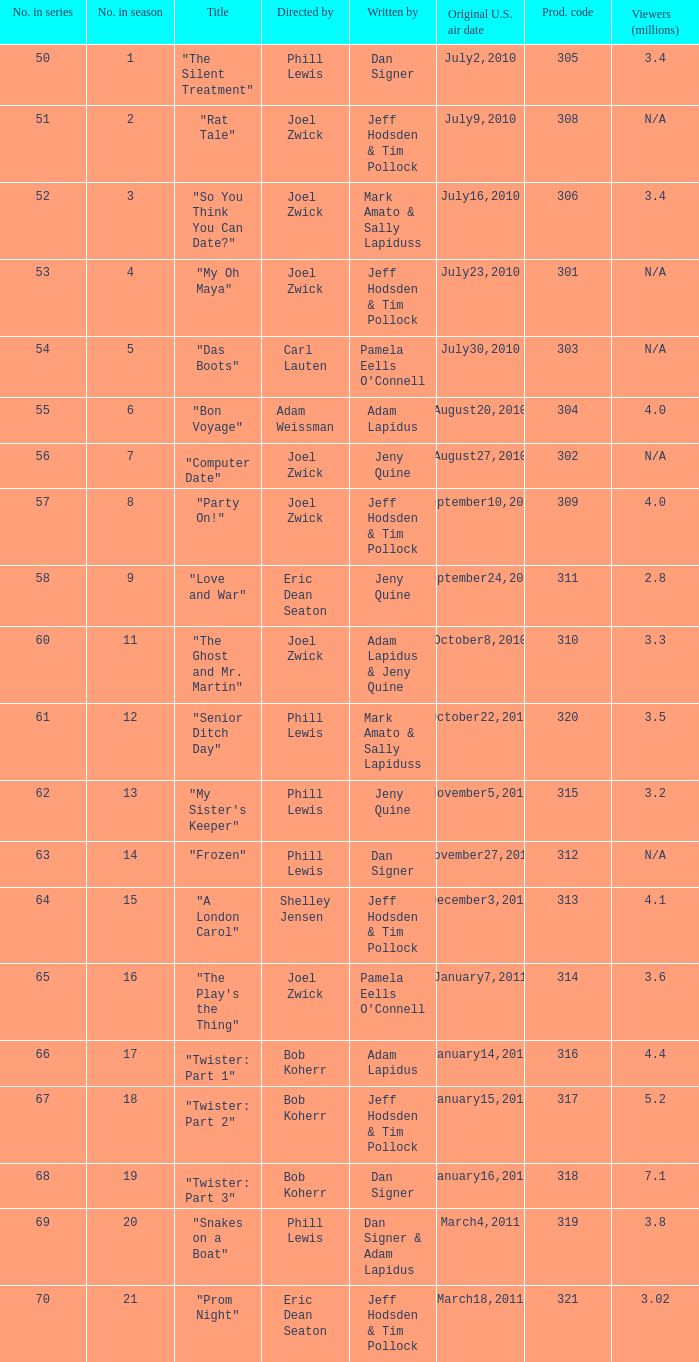Who was the directed for the episode titled "twister: part 1"? Bob Koherr. Would you be able to parse every entry in this table? {'header': ['No. in series', 'No. in season', 'Title', 'Directed by', 'Written by', 'Original U.S. air date', 'Prod. code', 'Viewers (millions)'], 'rows': [['50', '1', '"The Silent Treatment"', 'Phill Lewis', 'Dan Signer', 'July2,2010', '305', '3.4'], ['51', '2', '"Rat Tale"', 'Joel Zwick', 'Jeff Hodsden & Tim Pollock', 'July9,2010', '308', 'N/A'], ['52', '3', '"So You Think You Can Date?"', 'Joel Zwick', 'Mark Amato & Sally Lapiduss', 'July16,2010', '306', '3.4'], ['53', '4', '"My Oh Maya"', 'Joel Zwick', 'Jeff Hodsden & Tim Pollock', 'July23,2010', '301', 'N/A'], ['54', '5', '"Das Boots"', 'Carl Lauten', "Pamela Eells O'Connell", 'July30,2010', '303', 'N/A'], ['55', '6', '"Bon Voyage"', 'Adam Weissman', 'Adam Lapidus', 'August20,2010', '304', '4.0'], ['56', '7', '"Computer Date"', 'Joel Zwick', 'Jeny Quine', 'August27,2010', '302', 'N/A'], ['57', '8', '"Party On!"', 'Joel Zwick', 'Jeff Hodsden & Tim Pollock', 'September10,2010', '309', '4.0'], ['58', '9', '"Love and War"', 'Eric Dean Seaton', 'Jeny Quine', 'September24,2010', '311', '2.8'], ['60', '11', '"The Ghost and Mr. Martin"', 'Joel Zwick', 'Adam Lapidus & Jeny Quine', 'October8,2010', '310', '3.3'], ['61', '12', '"Senior Ditch Day"', 'Phill Lewis', 'Mark Amato & Sally Lapiduss', 'October22,2010', '320', '3.5'], ['62', '13', '"My Sister\'s Keeper"', 'Phill Lewis', 'Jeny Quine', 'November5,2010', '315', '3.2'], ['63', '14', '"Frozen"', 'Phill Lewis', 'Dan Signer', 'November27,2010', '312', 'N/A'], ['64', '15', '"A London Carol"', 'Shelley Jensen', 'Jeff Hodsden & Tim Pollock', 'December3,2010', '313', '4.1'], ['65', '16', '"The Play\'s the Thing"', 'Joel Zwick', "Pamela Eells O'Connell", 'January7,2011', '314', '3.6'], ['66', '17', '"Twister: Part 1"', 'Bob Koherr', 'Adam Lapidus', 'January14,2011', '316', '4.4'], ['67', '18', '"Twister: Part 2"', 'Bob Koherr', 'Jeff Hodsden & Tim Pollock', 'January15,2011', '317', '5.2'], ['68', '19', '"Twister: Part 3"', 'Bob Koherr', 'Dan Signer', 'January16,2011', '318', '7.1'], ['69', '20', '"Snakes on a Boat"', 'Phill Lewis', 'Dan Signer & Adam Lapidus', 'March4,2011', '319', '3.8'], ['70', '21', '"Prom Night"', 'Eric Dean Seaton', 'Jeff Hodsden & Tim Pollock', 'March18,2011', '321', '3.02']]} 